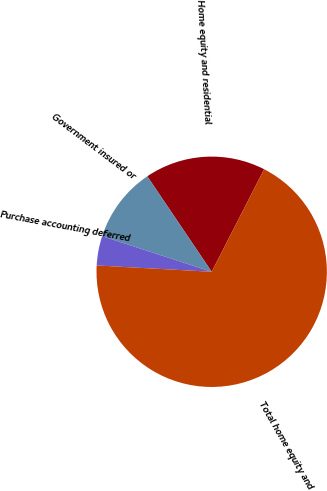Convert chart. <chart><loc_0><loc_0><loc_500><loc_500><pie_chart><fcel>Home equity and residential<fcel>Government insured or<fcel>Purchase accounting deferred<fcel>Total home equity and<nl><fcel>16.97%<fcel>10.55%<fcel>4.13%<fcel>68.35%<nl></chart> 